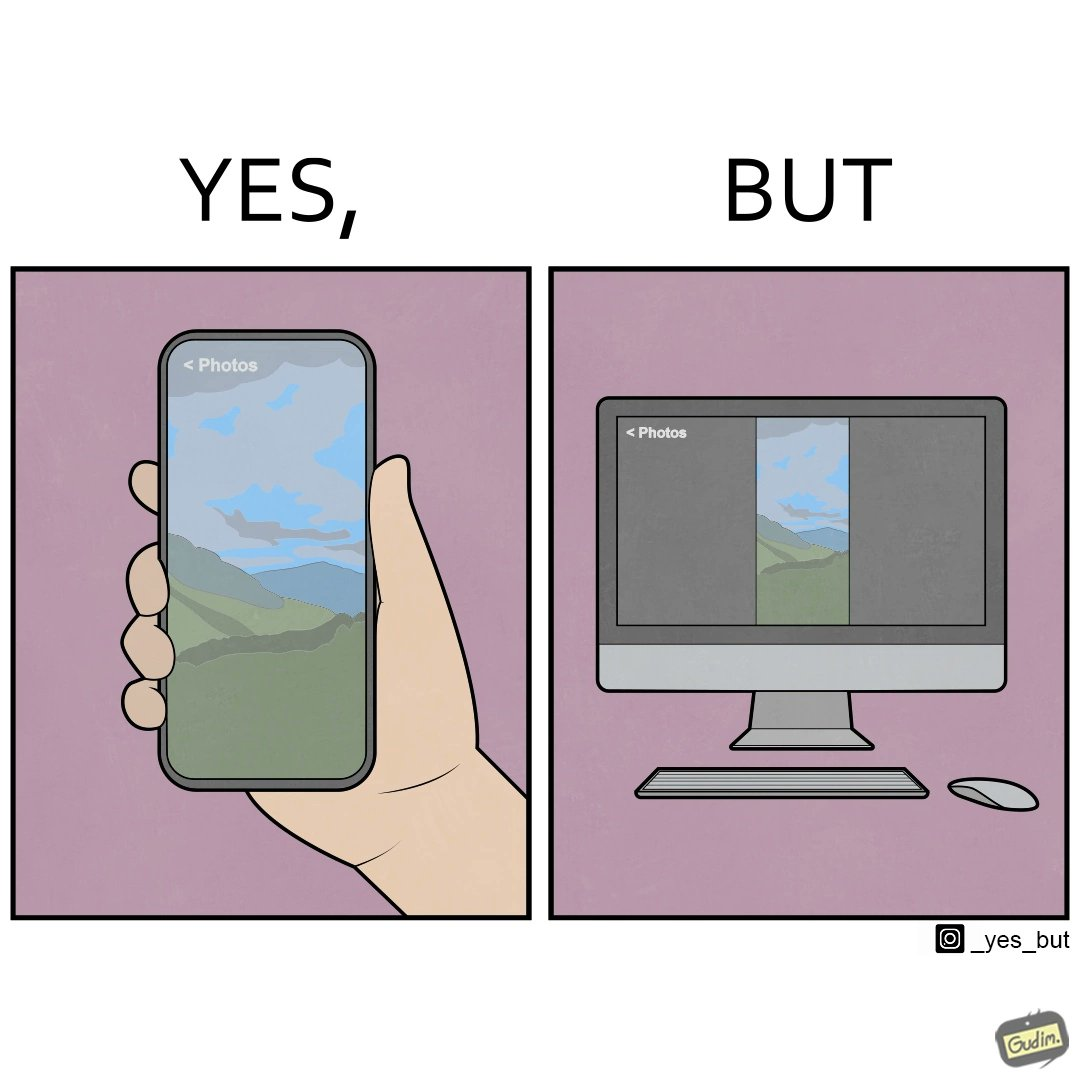Describe the content of this image. This image is funny, as when using the "photos" app on mobile, it shows you images perfectly, which fill the entire screen, but when viewing the same photos on the computer monitor, the same images have a very limited coverage of the screen. 